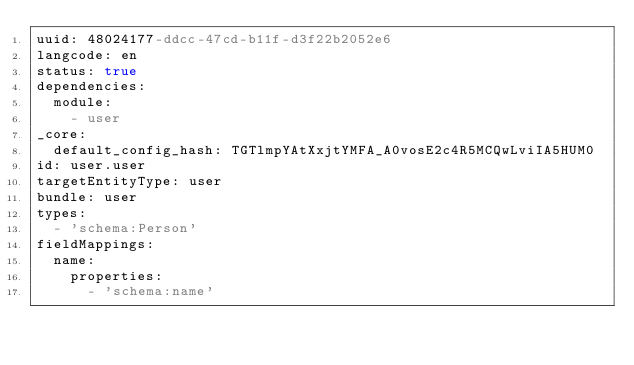<code> <loc_0><loc_0><loc_500><loc_500><_YAML_>uuid: 48024177-ddcc-47cd-b11f-d3f22b2052e6
langcode: en
status: true
dependencies:
  module:
    - user
_core:
  default_config_hash: TGTlmpYAtXxjtYMFA_A0vosE2c4R5MCQwLviIA5HUM0
id: user.user
targetEntityType: user
bundle: user
types:
  - 'schema:Person'
fieldMappings:
  name:
    properties:
      - 'schema:name'
</code> 